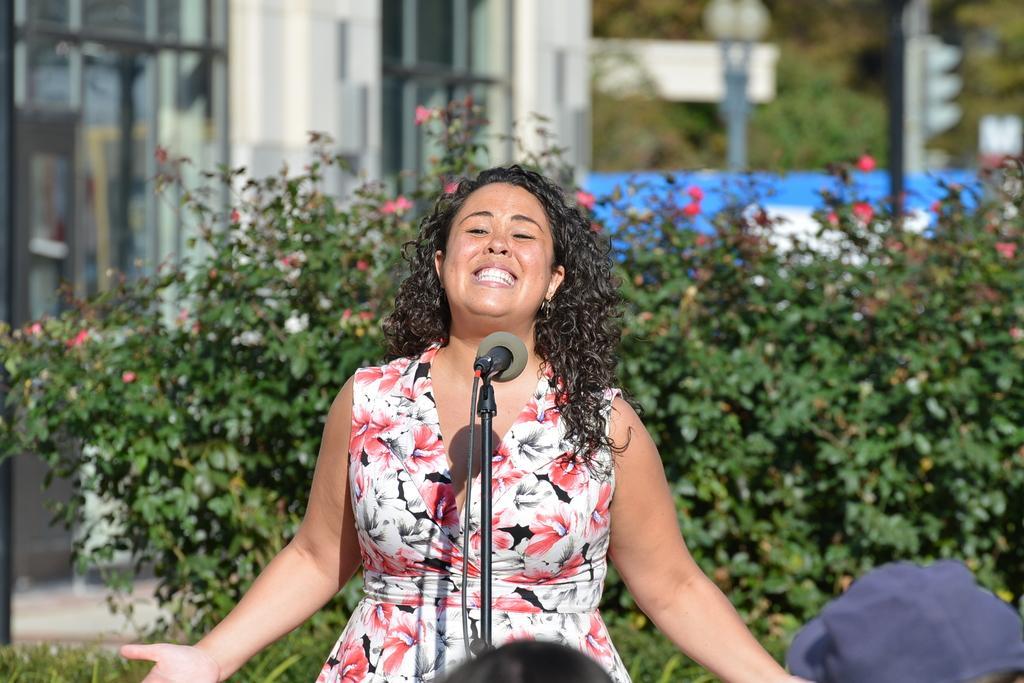Please provide a concise description of this image. In this image there is a woman standing and singing, there is a microphone, there is a stand, there is a wire, there are two persons towards the bottom of the image, there is a plant, there are flowers, there is a building towards the left of the image, there are poles, there are lights, there are boards. 